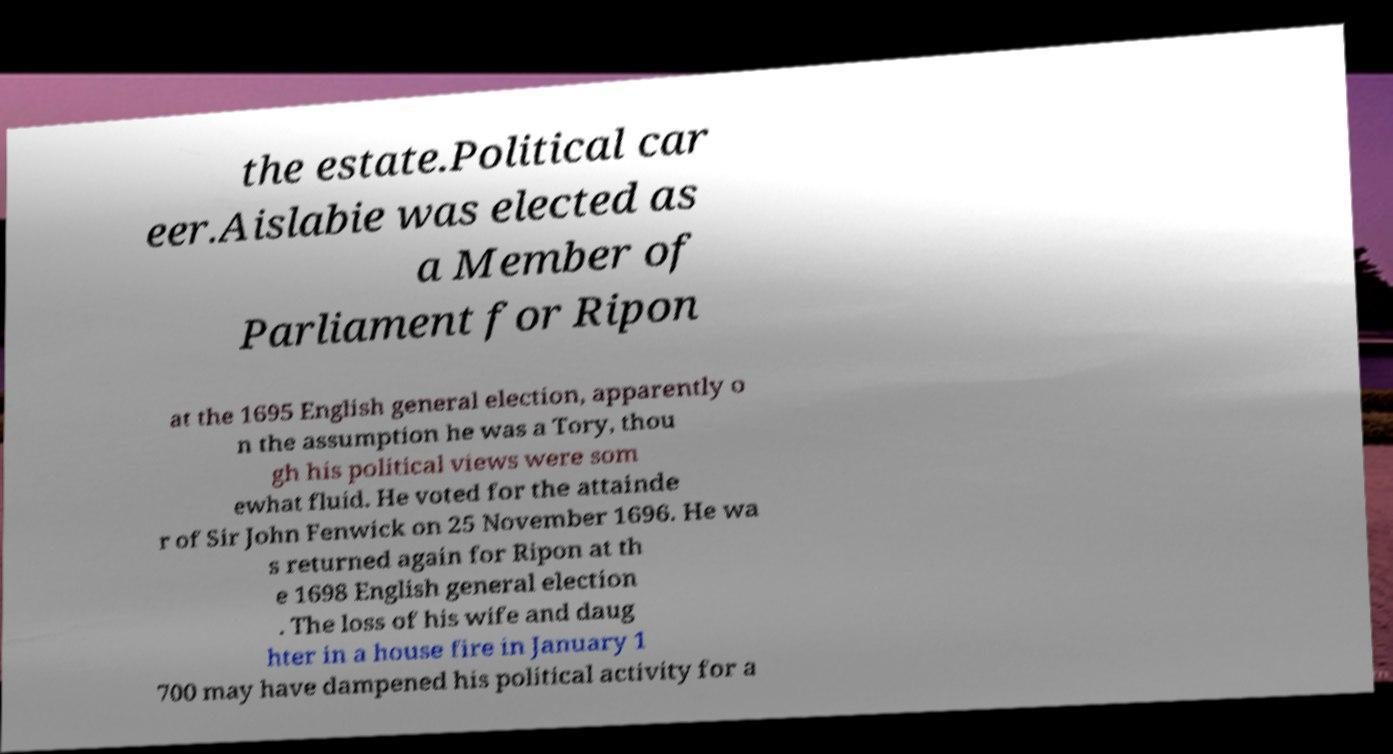Please identify and transcribe the text found in this image. the estate.Political car eer.Aislabie was elected as a Member of Parliament for Ripon at the 1695 English general election, apparently o n the assumption he was a Tory, thou gh his political views were som ewhat fluid. He voted for the attainde r of Sir John Fenwick on 25 November 1696. He wa s returned again for Ripon at th e 1698 English general election . The loss of his wife and daug hter in a house fire in January 1 700 may have dampened his political activity for a 